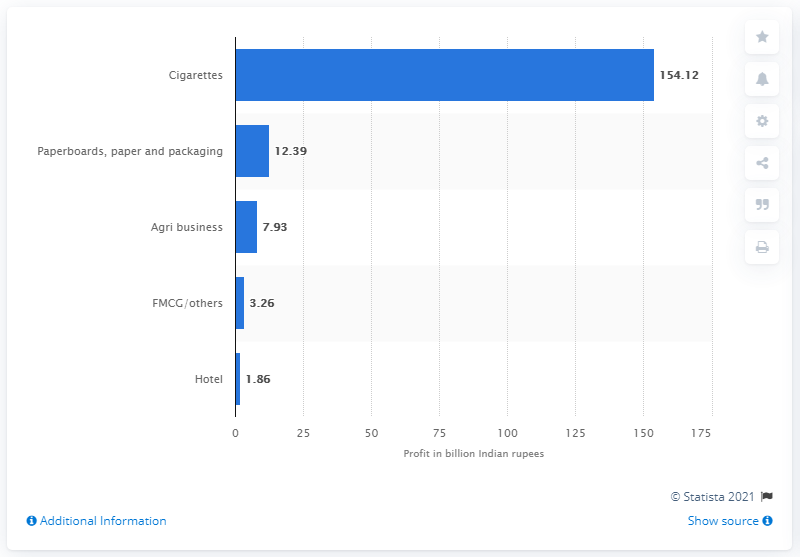Indicate a few pertinent items in this graphic. In the fiscal year 2019, ITC, a leading Indian cigarette company, generated a total revenue of 154.12 crores in the cigarette segment. 